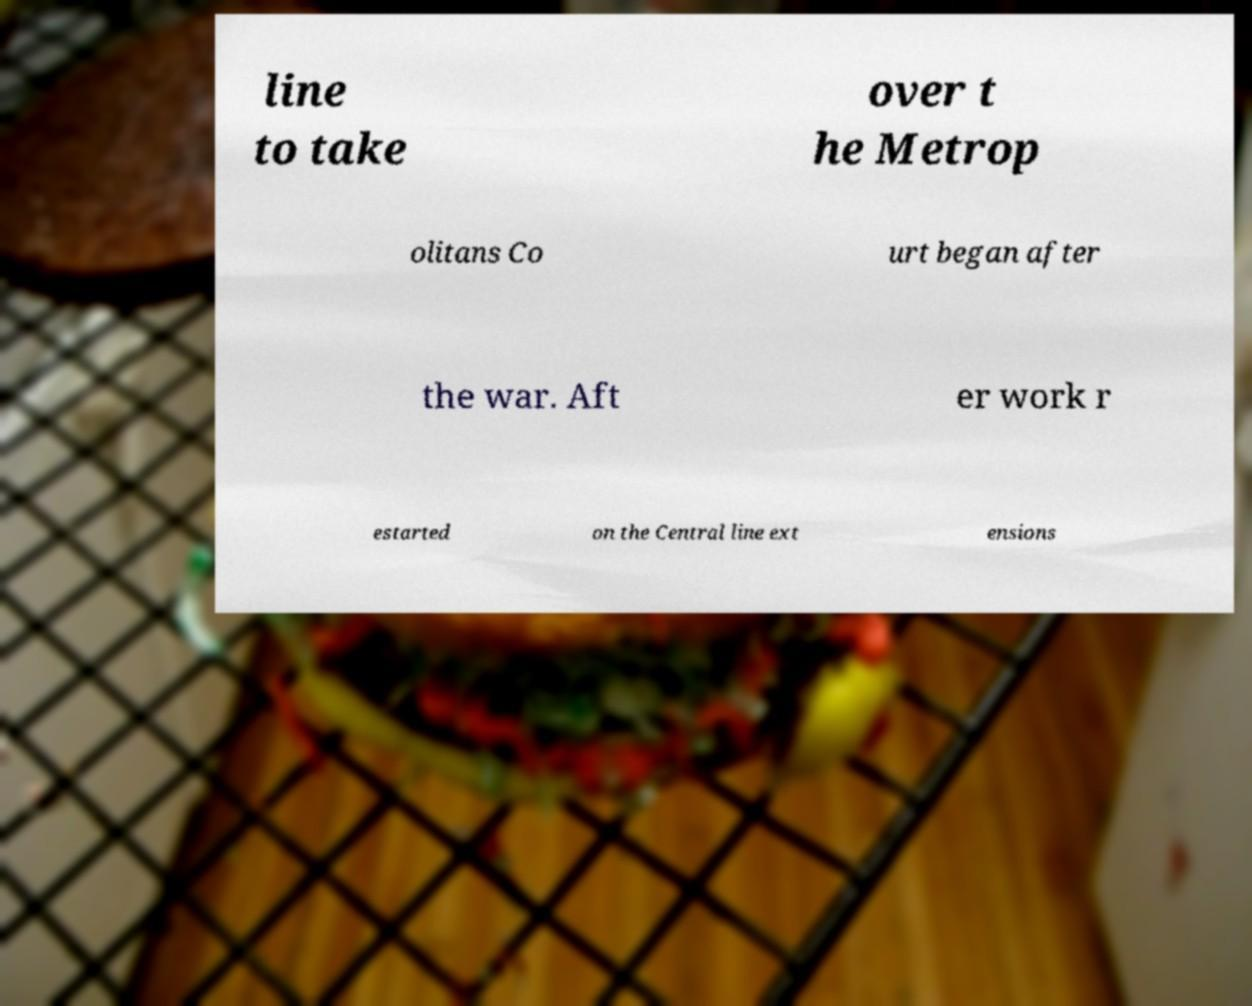Could you extract and type out the text from this image? line to take over t he Metrop olitans Co urt began after the war. Aft er work r estarted on the Central line ext ensions 